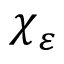<formula> <loc_0><loc_0><loc_500><loc_500>\chi _ { \varepsilon }</formula> 